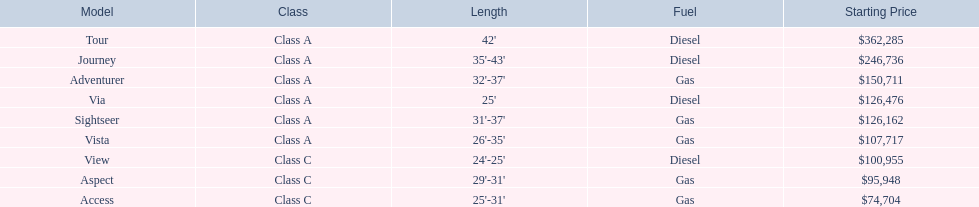In the table, which models operate on diesel fuel? Tour, Journey, Via, View. Among those models, which ones belong to class a? Tour, Journey, Via. Which ones have a length exceeding 35 feet? Tour, Journey. Lastly, which of the two models has a higher price? Tour. 